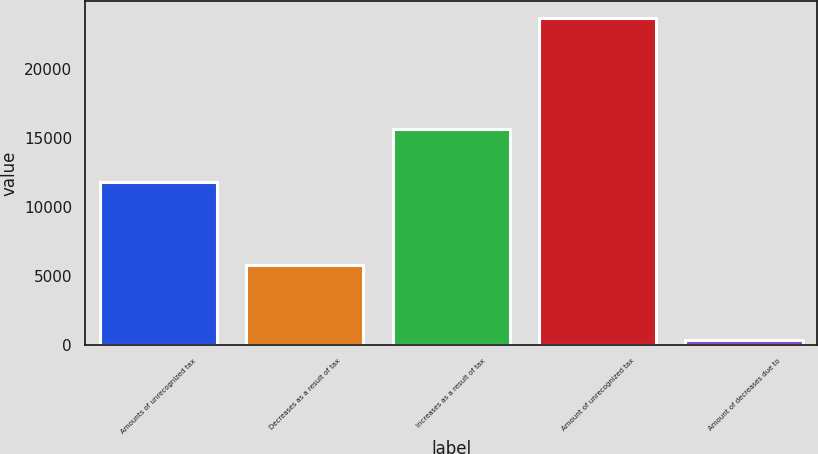<chart> <loc_0><loc_0><loc_500><loc_500><bar_chart><fcel>Amounts of unrecognized tax<fcel>Decreases as a result of tax<fcel>Increases as a result of tax<fcel>Amount of unrecognized tax<fcel>Amount of decreases due to<nl><fcel>11825<fcel>5771.3<fcel>15667<fcel>23743<fcel>320<nl></chart> 